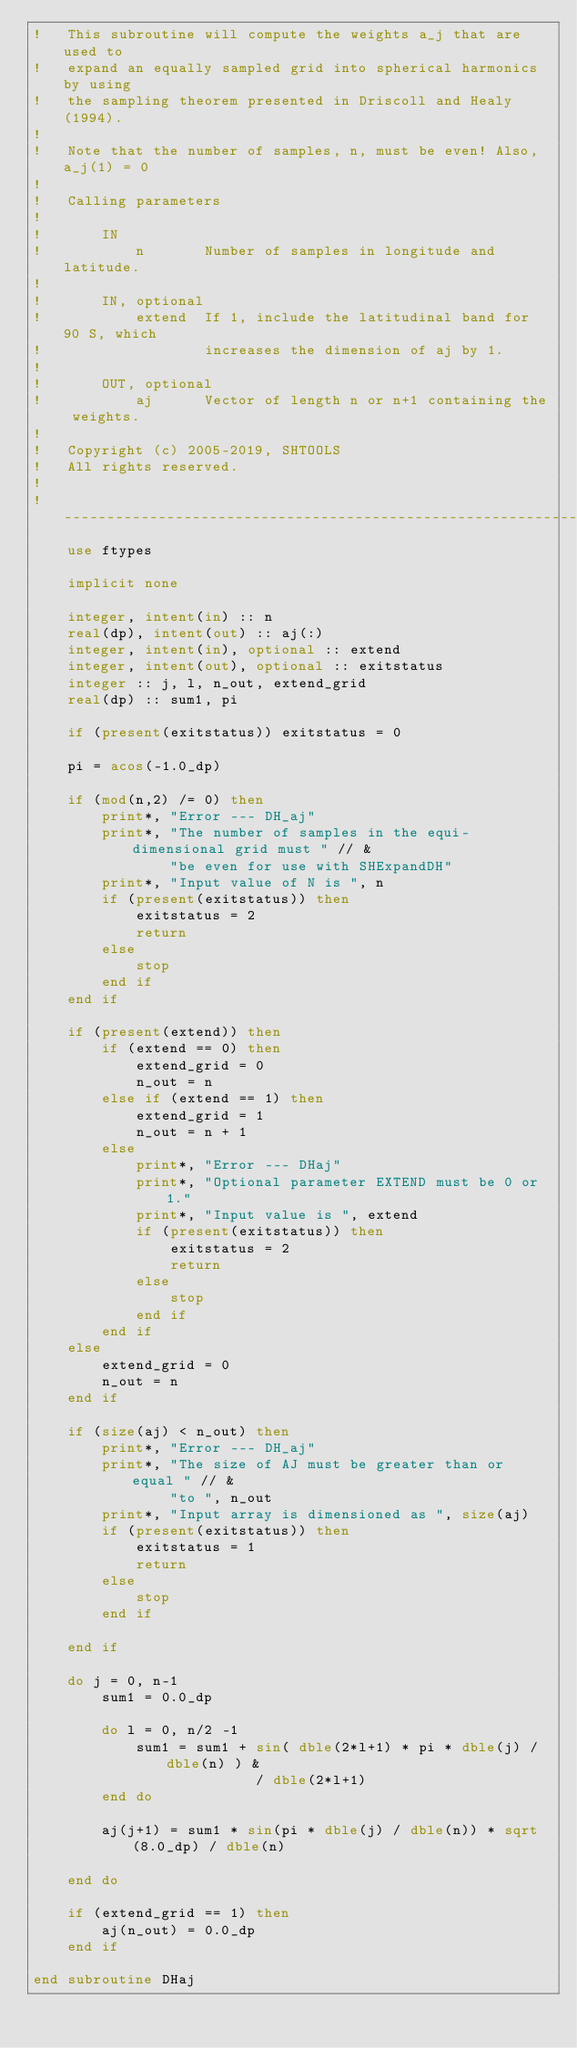Convert code to text. <code><loc_0><loc_0><loc_500><loc_500><_FORTRAN_>!   This subroutine will compute the weights a_j that are used to
!   expand an equally sampled grid into spherical harmonics by using
!   the sampling theorem presented in Driscoll and Healy (1994).
!
!   Note that the number of samples, n, must be even! Also, a_j(1) = 0
!
!   Calling parameters
!
!       IN
!           n       Number of samples in longitude and latitude.
!
!       IN, optional
!           extend  If 1, include the latitudinal band for 90 S, which
!                   increases the dimension of aj by 1.
!
!       OUT, optional
!           aj      Vector of length n or n+1 containing the weights.
!
!   Copyright (c) 2005-2019, SHTOOLS
!   All rights reserved.
!
!------------------------------------------------------------------------------
    use ftypes

    implicit none

    integer, intent(in) :: n
    real(dp), intent(out) :: aj(:)
    integer, intent(in), optional :: extend
    integer, intent(out), optional :: exitstatus
    integer :: j, l, n_out, extend_grid
    real(dp) :: sum1, pi

    if (present(exitstatus)) exitstatus = 0

    pi = acos(-1.0_dp)

    if (mod(n,2) /= 0) then
        print*, "Error --- DH_aj"
        print*, "The number of samples in the equi-dimensional grid must " // &
                "be even for use with SHExpandDH"
        print*, "Input value of N is ", n
        if (present(exitstatus)) then
            exitstatus = 2
            return
        else
            stop
        end if
    end if

    if (present(extend)) then
        if (extend == 0) then
            extend_grid = 0
            n_out = n
        else if (extend == 1) then
            extend_grid = 1
            n_out = n + 1
        else
            print*, "Error --- DHaj"
            print*, "Optional parameter EXTEND must be 0 or 1."
            print*, "Input value is ", extend
            if (present(exitstatus)) then
                exitstatus = 2
                return
            else
                stop
            end if
        end if
    else
        extend_grid = 0
        n_out = n
    end if

    if (size(aj) < n_out) then
        print*, "Error --- DH_aj"
        print*, "The size of AJ must be greater than or equal " // &
                "to ", n_out
        print*, "Input array is dimensioned as ", size(aj)
        if (present(exitstatus)) then
            exitstatus = 1
            return
        else
            stop
        end if

    end if

    do j = 0, n-1
        sum1 = 0.0_dp

        do l = 0, n/2 -1
            sum1 = sum1 + sin( dble(2*l+1) * pi * dble(j) / dble(n) ) &
                          / dble(2*l+1)
        end do

        aj(j+1) = sum1 * sin(pi * dble(j) / dble(n)) * sqrt(8.0_dp) / dble(n)

    end do

    if (extend_grid == 1) then
        aj(n_out) = 0.0_dp
    end if

end subroutine DHaj
</code> 